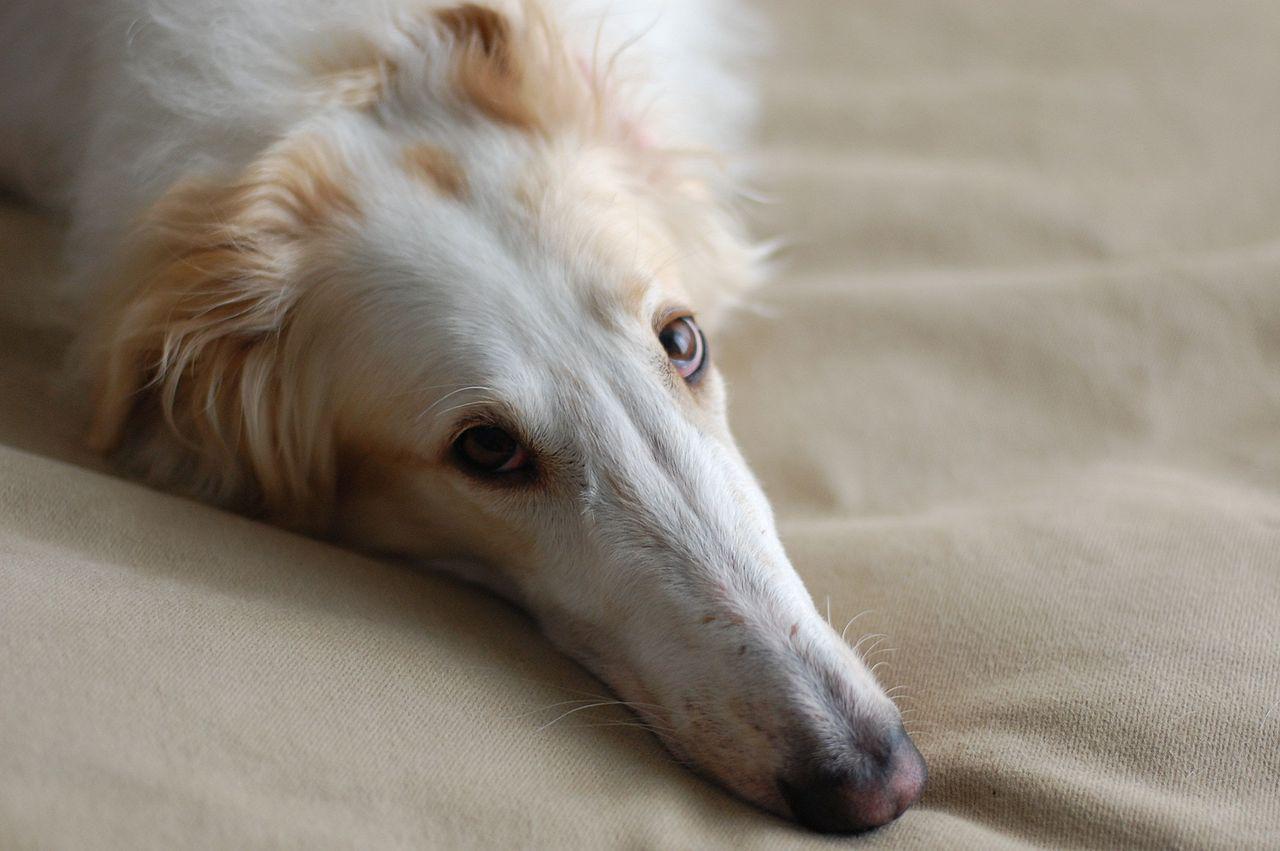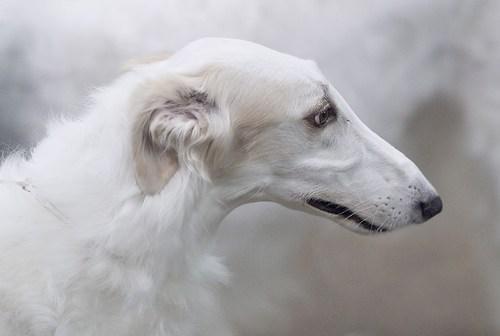The first image is the image on the left, the second image is the image on the right. Considering the images on both sides, is "All dogs in the images are on the grass." valid? Answer yes or no. No. 